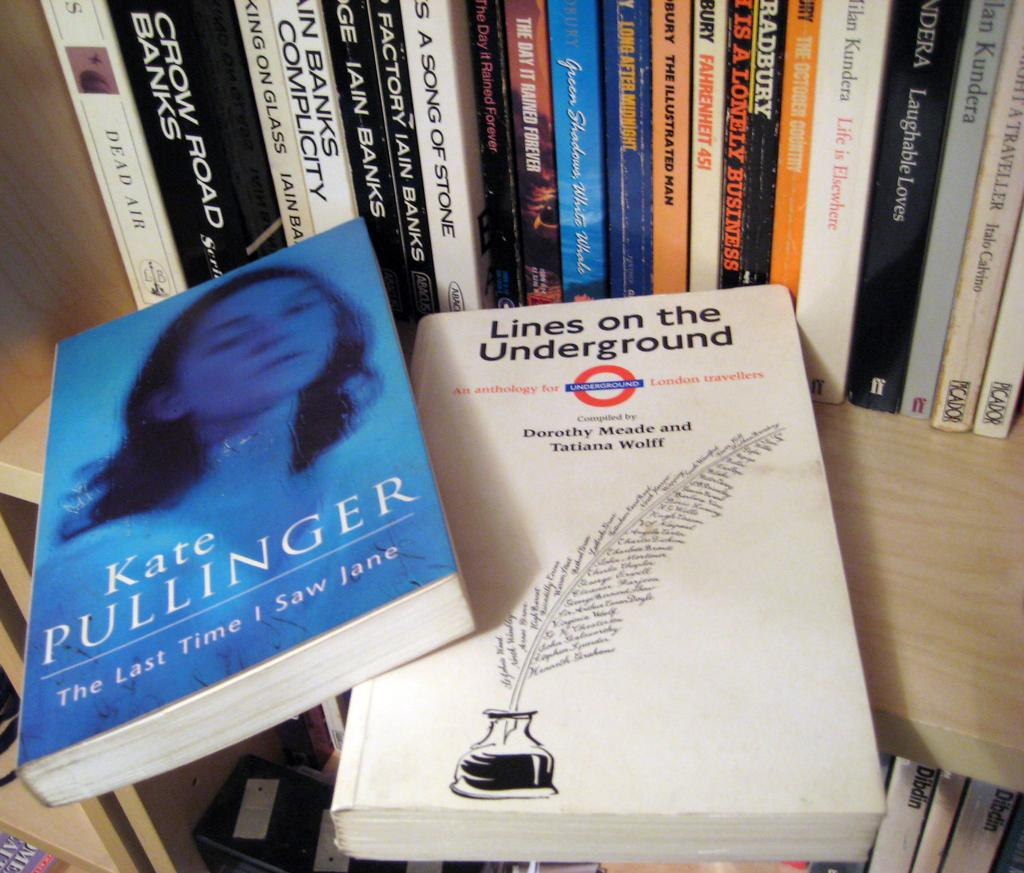<image>
Summarize the visual content of the image. A book by Kate Pullinger sits on a shelf next to several other books. 